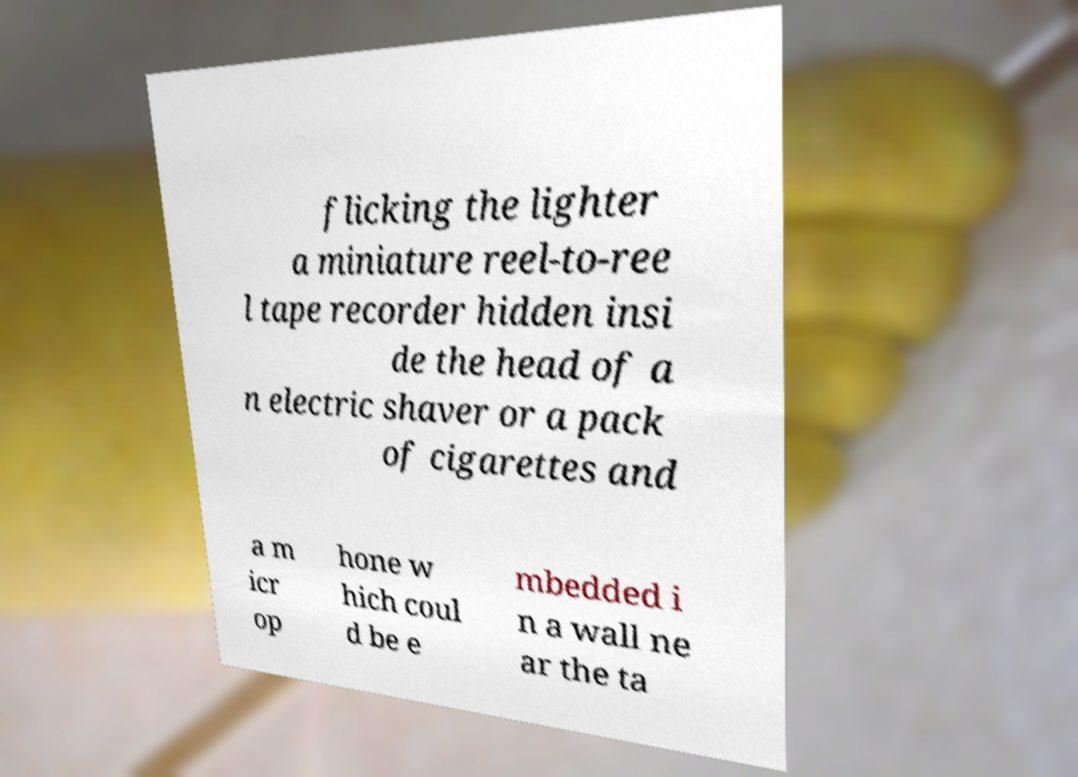Could you extract and type out the text from this image? flicking the lighter a miniature reel-to-ree l tape recorder hidden insi de the head of a n electric shaver or a pack of cigarettes and a m icr op hone w hich coul d be e mbedded i n a wall ne ar the ta 